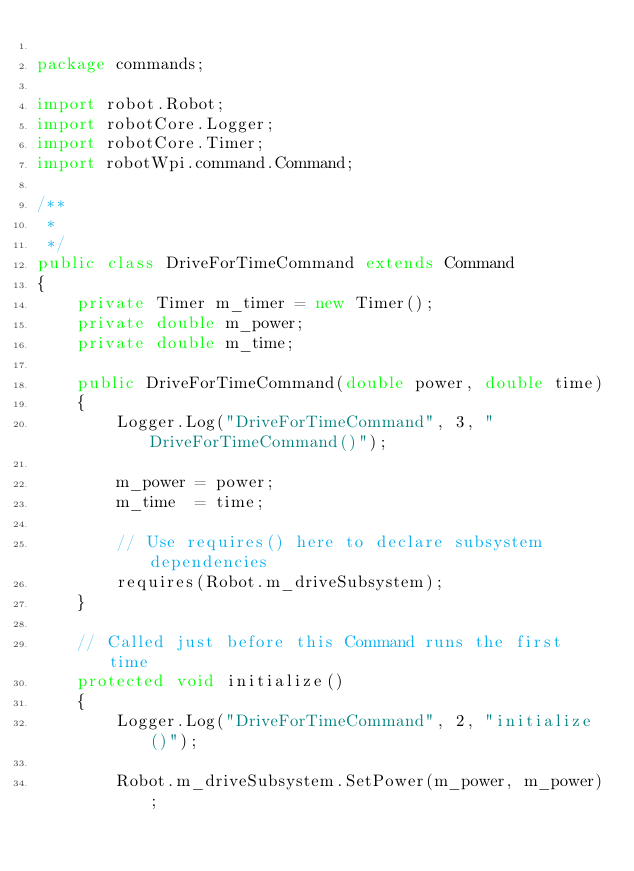Convert code to text. <code><loc_0><loc_0><loc_500><loc_500><_Java_>
package commands;

import robot.Robot;
import robotCore.Logger;
import robotCore.Timer;
import robotWpi.command.Command;

/**
 *
 */
public class DriveForTimeCommand extends Command 
{
    private Timer m_timer = new Timer();
    private double m_power;
    private double m_time;

	public DriveForTimeCommand(double power, double time) 
    {
    	Logger.Log("DriveForTimeCommand", 3, "DriveForTimeCommand()");
    	
    	m_power	= power;
    	m_time	= time;
    	
        // Use requires() here to declare subsystem dependencies
        requires(Robot.m_driveSubsystem);
    }

    // Called just before this Command runs the first time
    protected void initialize() 
    {
    	Logger.Log("DriveForTimeCommand", 2, "initialize()");
    	
    	Robot.m_driveSubsystem.SetPower(m_power, m_power);</code> 